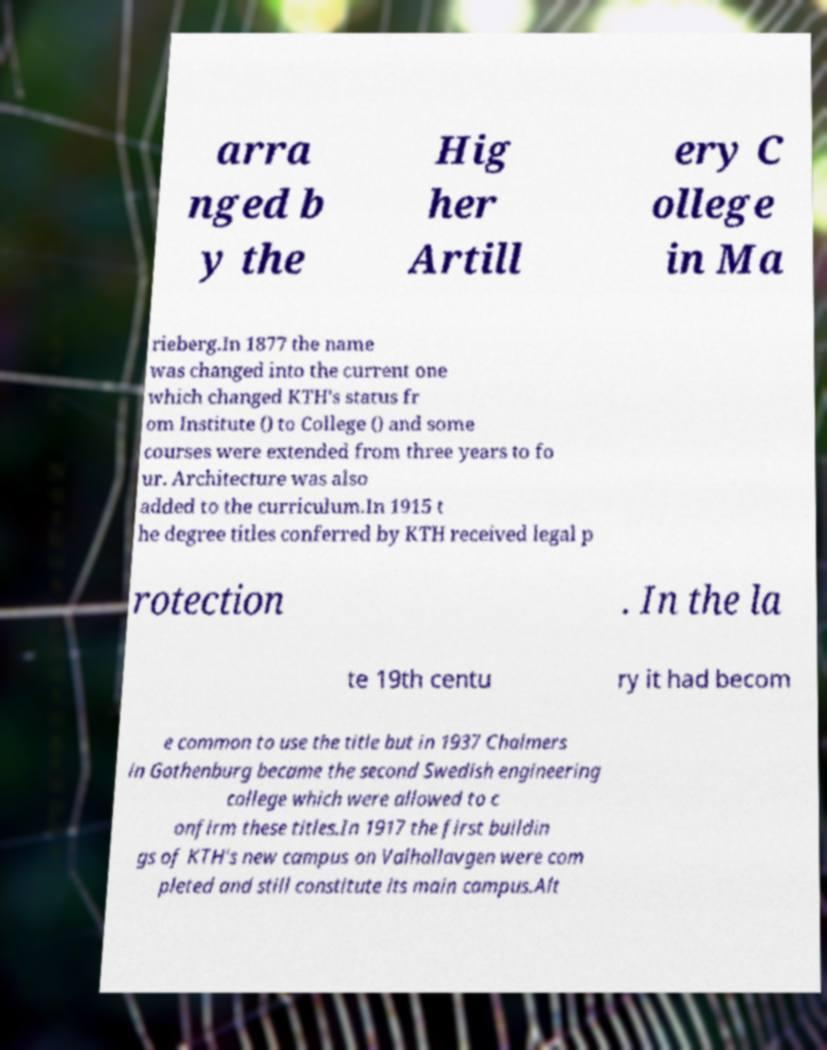What messages or text are displayed in this image? I need them in a readable, typed format. arra nged b y the Hig her Artill ery C ollege in Ma rieberg.In 1877 the name was changed into the current one which changed KTH's status fr om Institute () to College () and some courses were extended from three years to fo ur. Architecture was also added to the curriculum.In 1915 t he degree titles conferred by KTH received legal p rotection . In the la te 19th centu ry it had becom e common to use the title but in 1937 Chalmers in Gothenburg became the second Swedish engineering college which were allowed to c onfirm these titles.In 1917 the first buildin gs of KTH's new campus on Valhallavgen were com pleted and still constitute its main campus.Alt 